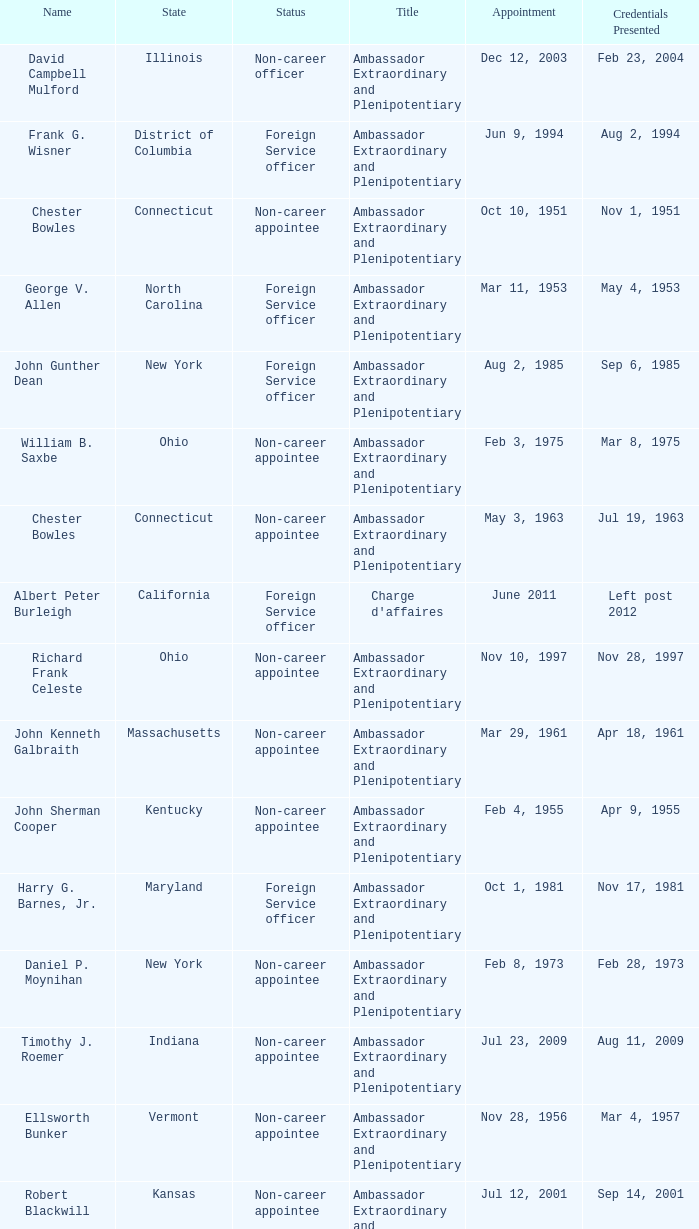When were the credentials presented for new jersey with a status of foreign service officer? Aug 14, 1992. 